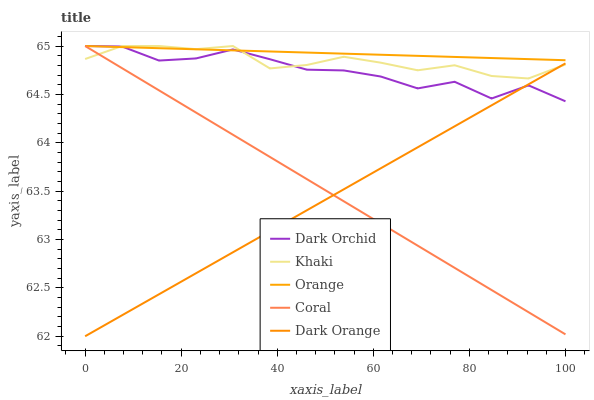Does Coral have the minimum area under the curve?
Answer yes or no. No. Does Coral have the maximum area under the curve?
Answer yes or no. No. Is Dark Orange the smoothest?
Answer yes or no. No. Is Dark Orange the roughest?
Answer yes or no. No. Does Coral have the lowest value?
Answer yes or no. No. Does Dark Orange have the highest value?
Answer yes or no. No. Is Dark Orange less than Orange?
Answer yes or no. Yes. Is Orange greater than Dark Orange?
Answer yes or no. Yes. Does Dark Orange intersect Orange?
Answer yes or no. No. 